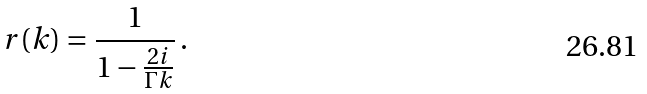Convert formula to latex. <formula><loc_0><loc_0><loc_500><loc_500>r ( k ) = \frac { 1 } { 1 - \frac { 2 i } { \Gamma k } } \, .</formula> 